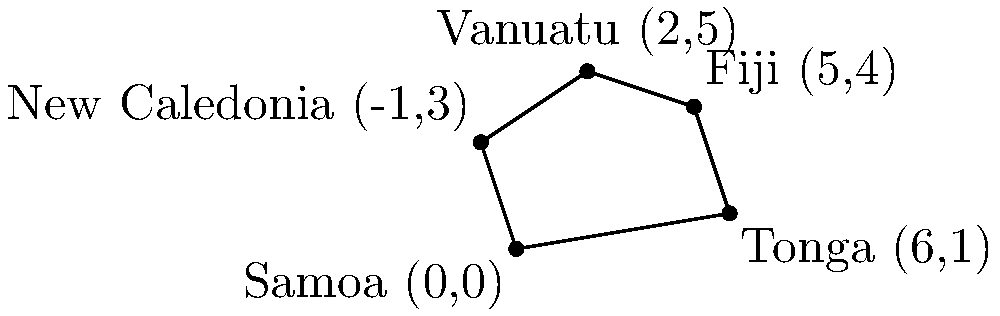On a coordinate system, five Polynesian islands are represented by the following points: Samoa (0,0), Tonga (6,1), Fiji (5,4), Vanuatu (2,5), and New Caledonia (-1,3). Calculate the area of the polygon formed by connecting these points in the given order. Round your answer to the nearest whole number. To find the area of this irregular polygon, we can use the Shoelace formula (also known as the surveyor's formula). The steps are as follows:

1) List the coordinates in order:
   (0,0), (6,1), (5,4), (2,5), (-1,3), (0,0) (repeat the first point at the end)

2) Apply the Shoelace formula:
   Area = $\frac{1}{2}|((x_1y_2 + x_2y_3 + ... + x_ny_1) - (y_1x_2 + y_2x_3 + ... + y_nx_1))|$

3) Substitute the values:
   Area = $\frac{1}{2}|(0(1) + 6(4) + 5(5) + 2(3) + (-1)(0)) - (0(6) + 1(5) + 4(2) + 5(-1) + 3(0))|$

4) Calculate:
   Area = $\frac{1}{2}|(0 + 24 + 25 + 6 + 0) - (0 + 5 + 8 - 5 + 0)|$
   Area = $\frac{1}{2}|55 - 8|$
   Area = $\frac{1}{2}(47)$
   Area = 23.5

5) Round to the nearest whole number:
   Area ≈ 24
Answer: 24 square units 